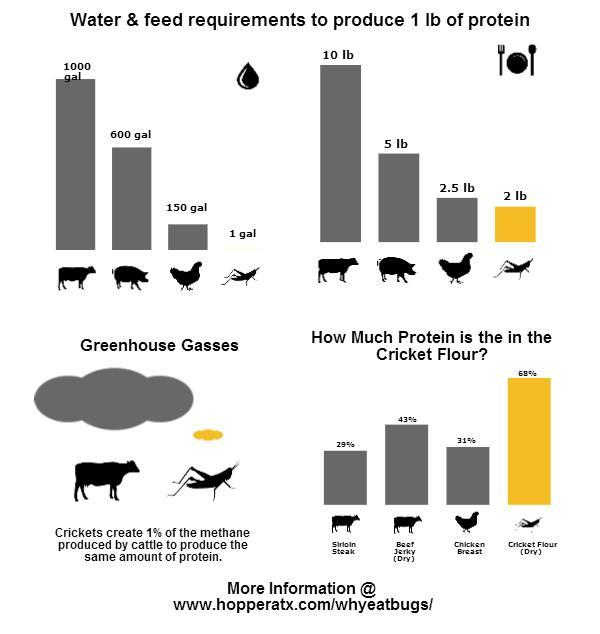How much protein is in the cricket flour?
Answer the question with a short phrase. 2 lb How much protein is in the chicken? 2.5 lb 